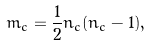Convert formula to latex. <formula><loc_0><loc_0><loc_500><loc_500>m _ { c } = \frac { 1 } { 2 } n _ { c } ( n _ { c } - 1 ) ,</formula> 